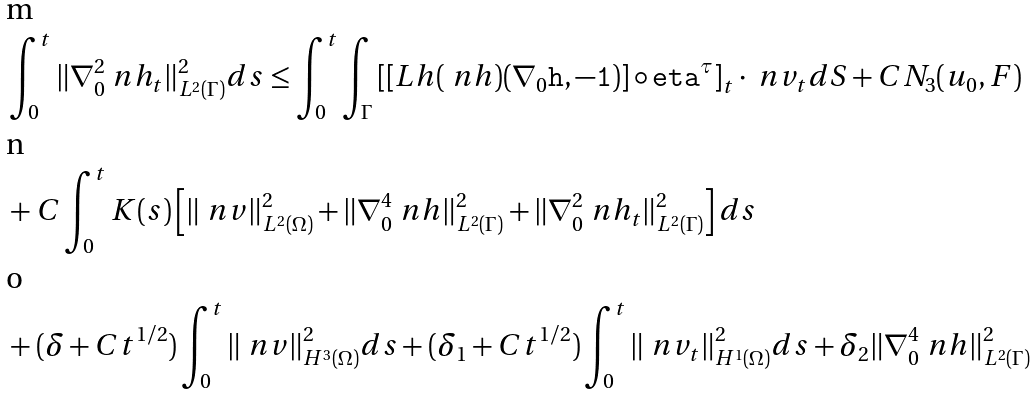<formula> <loc_0><loc_0><loc_500><loc_500>& \int _ { 0 } ^ { t } \| \nabla _ { 0 } ^ { 2 } \ n h _ { t } \| ^ { 2 } _ { L ^ { 2 } ( \Gamma ) } d s \leq \int _ { 0 } ^ { t } \int _ { \Gamma } \left [ [ L _ { \tt } h ( \ n h ) ( \nabla _ { 0 } \tt h , - 1 ) ] \circ \tt e t a ^ { \tau } \right ] _ { t } \cdot \ n v _ { t } d S + C N _ { 3 } ( u _ { 0 } , F ) \\ & + C \int _ { 0 } ^ { t } K ( s ) \left [ \| \ n v \| ^ { 2 } _ { L ^ { 2 } ( \Omega ) } + \| \nabla _ { 0 } ^ { 4 } \ n h \| ^ { 2 } _ { L ^ { 2 } ( \Gamma ) } + \| \nabla _ { 0 } ^ { 2 } \ n h _ { t } \| ^ { 2 } _ { L ^ { 2 } ( \Gamma ) } \right ] d s \\ & + ( \delta + C t ^ { 1 / 2 } ) \int _ { 0 } ^ { t } \| \ n v \| ^ { 2 } _ { H ^ { 3 } ( \Omega ) } d s + ( \delta _ { 1 } + C t ^ { 1 / 2 } ) \int _ { 0 } ^ { t } \| \ n v _ { t } \| ^ { 2 } _ { H ^ { 1 } ( \Omega ) } d s + \delta _ { 2 } \| \nabla _ { 0 } ^ { 4 } \ n h \| ^ { 2 } _ { L ^ { 2 } ( \Gamma ) }</formula> 